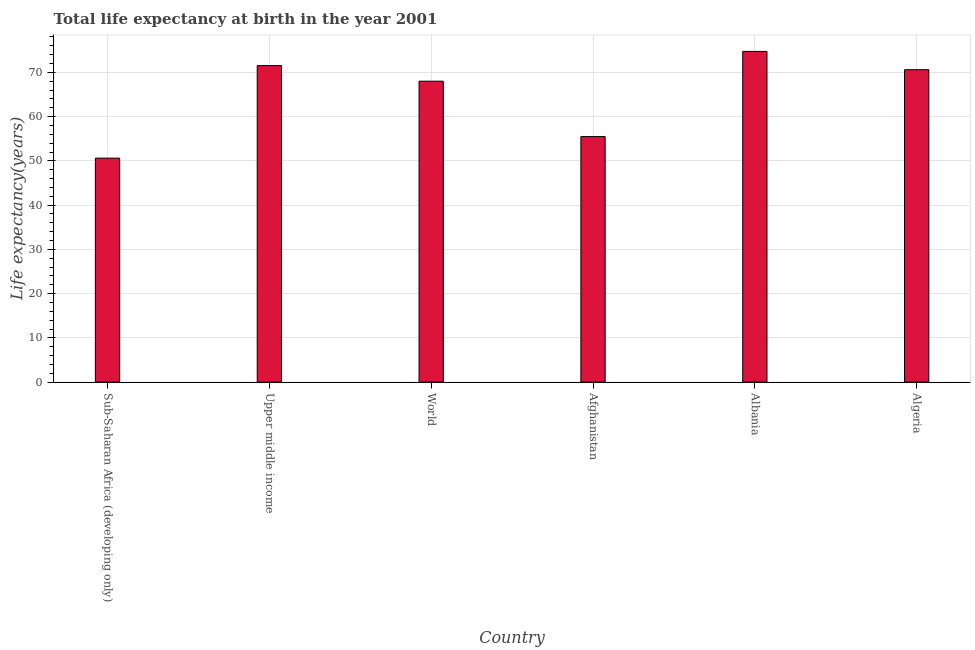Does the graph contain any zero values?
Your answer should be compact. No. What is the title of the graph?
Give a very brief answer. Total life expectancy at birth in the year 2001. What is the label or title of the Y-axis?
Keep it short and to the point. Life expectancy(years). What is the life expectancy at birth in Sub-Saharan Africa (developing only)?
Your answer should be very brief. 50.62. Across all countries, what is the maximum life expectancy at birth?
Give a very brief answer. 74.73. Across all countries, what is the minimum life expectancy at birth?
Give a very brief answer. 50.62. In which country was the life expectancy at birth maximum?
Your response must be concise. Albania. In which country was the life expectancy at birth minimum?
Offer a very short reply. Sub-Saharan Africa (developing only). What is the sum of the life expectancy at birth?
Keep it short and to the point. 390.97. What is the difference between the life expectancy at birth in Upper middle income and World?
Offer a terse response. 3.52. What is the average life expectancy at birth per country?
Keep it short and to the point. 65.16. What is the median life expectancy at birth?
Your answer should be very brief. 69.3. In how many countries, is the life expectancy at birth greater than 18 years?
Provide a succinct answer. 6. What is the ratio of the life expectancy at birth in Albania to that in World?
Your response must be concise. 1.1. Is the life expectancy at birth in Albania less than that in Sub-Saharan Africa (developing only)?
Provide a succinct answer. No. Is the difference between the life expectancy at birth in Afghanistan and Algeria greater than the difference between any two countries?
Your answer should be very brief. No. What is the difference between the highest and the second highest life expectancy at birth?
Give a very brief answer. 3.21. Is the sum of the life expectancy at birth in Afghanistan and Albania greater than the maximum life expectancy at birth across all countries?
Provide a short and direct response. Yes. What is the difference between the highest and the lowest life expectancy at birth?
Your answer should be very brief. 24.12. What is the difference between two consecutive major ticks on the Y-axis?
Keep it short and to the point. 10. Are the values on the major ticks of Y-axis written in scientific E-notation?
Provide a succinct answer. No. What is the Life expectancy(years) of Sub-Saharan Africa (developing only)?
Provide a succinct answer. 50.62. What is the Life expectancy(years) in Upper middle income?
Your answer should be very brief. 71.52. What is the Life expectancy(years) of World?
Ensure brevity in your answer.  68. What is the Life expectancy(years) of Afghanistan?
Give a very brief answer. 55.49. What is the Life expectancy(years) in Albania?
Make the answer very short. 74.73. What is the Life expectancy(years) of Algeria?
Your answer should be very brief. 70.6. What is the difference between the Life expectancy(years) in Sub-Saharan Africa (developing only) and Upper middle income?
Make the answer very short. -20.9. What is the difference between the Life expectancy(years) in Sub-Saharan Africa (developing only) and World?
Your answer should be compact. -17.38. What is the difference between the Life expectancy(years) in Sub-Saharan Africa (developing only) and Afghanistan?
Ensure brevity in your answer.  -4.87. What is the difference between the Life expectancy(years) in Sub-Saharan Africa (developing only) and Albania?
Offer a very short reply. -24.12. What is the difference between the Life expectancy(years) in Sub-Saharan Africa (developing only) and Algeria?
Make the answer very short. -19.98. What is the difference between the Life expectancy(years) in Upper middle income and World?
Ensure brevity in your answer.  3.52. What is the difference between the Life expectancy(years) in Upper middle income and Afghanistan?
Your response must be concise. 16.04. What is the difference between the Life expectancy(years) in Upper middle income and Albania?
Your answer should be compact. -3.21. What is the difference between the Life expectancy(years) in Upper middle income and Algeria?
Offer a terse response. 0.92. What is the difference between the Life expectancy(years) in World and Afghanistan?
Your answer should be compact. 12.52. What is the difference between the Life expectancy(years) in World and Albania?
Ensure brevity in your answer.  -6.73. What is the difference between the Life expectancy(years) in World and Algeria?
Your response must be concise. -2.6. What is the difference between the Life expectancy(years) in Afghanistan and Albania?
Give a very brief answer. -19.25. What is the difference between the Life expectancy(years) in Afghanistan and Algeria?
Your answer should be very brief. -15.11. What is the difference between the Life expectancy(years) in Albania and Algeria?
Provide a short and direct response. 4.13. What is the ratio of the Life expectancy(years) in Sub-Saharan Africa (developing only) to that in Upper middle income?
Provide a succinct answer. 0.71. What is the ratio of the Life expectancy(years) in Sub-Saharan Africa (developing only) to that in World?
Keep it short and to the point. 0.74. What is the ratio of the Life expectancy(years) in Sub-Saharan Africa (developing only) to that in Afghanistan?
Your response must be concise. 0.91. What is the ratio of the Life expectancy(years) in Sub-Saharan Africa (developing only) to that in Albania?
Ensure brevity in your answer.  0.68. What is the ratio of the Life expectancy(years) in Sub-Saharan Africa (developing only) to that in Algeria?
Provide a succinct answer. 0.72. What is the ratio of the Life expectancy(years) in Upper middle income to that in World?
Your answer should be compact. 1.05. What is the ratio of the Life expectancy(years) in Upper middle income to that in Afghanistan?
Provide a succinct answer. 1.29. What is the ratio of the Life expectancy(years) in Upper middle income to that in Albania?
Give a very brief answer. 0.96. What is the ratio of the Life expectancy(years) in World to that in Afghanistan?
Ensure brevity in your answer.  1.23. What is the ratio of the Life expectancy(years) in World to that in Albania?
Make the answer very short. 0.91. What is the ratio of the Life expectancy(years) in World to that in Algeria?
Offer a very short reply. 0.96. What is the ratio of the Life expectancy(years) in Afghanistan to that in Albania?
Offer a very short reply. 0.74. What is the ratio of the Life expectancy(years) in Afghanistan to that in Algeria?
Your answer should be very brief. 0.79. What is the ratio of the Life expectancy(years) in Albania to that in Algeria?
Make the answer very short. 1.06. 